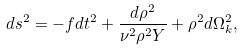<formula> <loc_0><loc_0><loc_500><loc_500>d s ^ { 2 } = - f d t ^ { 2 } + \frac { d \rho ^ { 2 } } { \nu ^ { 2 } \rho ^ { 2 } Y } + \rho ^ { 2 } d \Omega ^ { 2 } _ { k } ,</formula> 